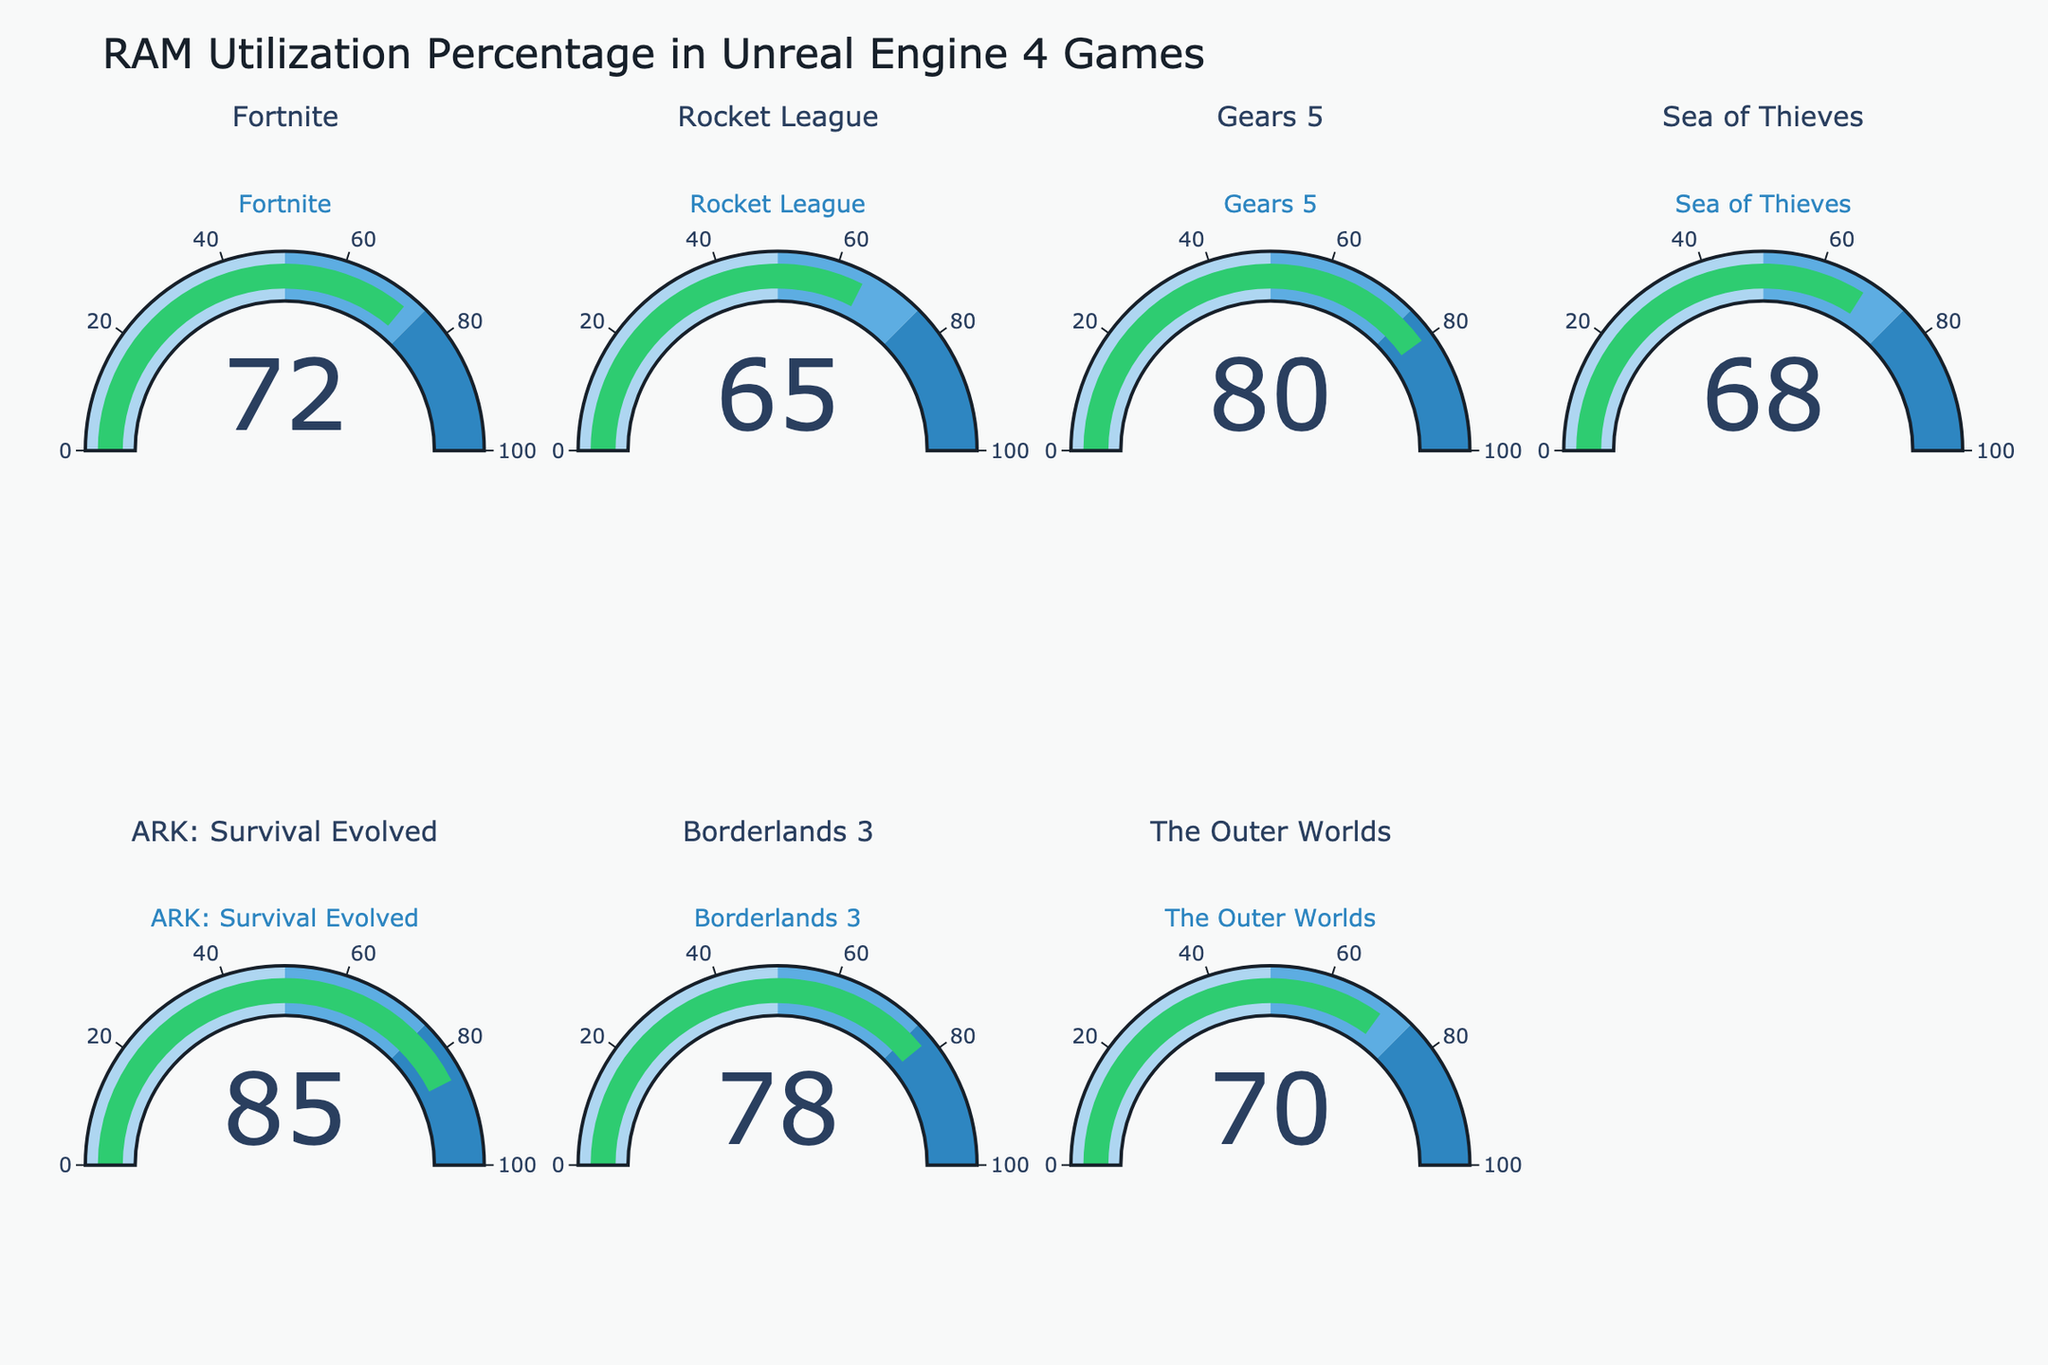How many games are displayed in the figure? Count the number of gauge charts displayed in the figure.
Answer: 7 What is the highest RAM utilization percentage displayed in the figure? Find the gauge chart with the highest value.
Answer: 85 What's the average RAM utilization percentage across all games? Sum all the RAM utilization percentages and then divide by the number of games: (72 + 65 + 80 + 68 + 85 + 78 + 70) / 7 = 74
Answer: 74 Which game has the lowest RAM utilization percentage? Identify the gauge chart with the smallest value.
Answer: Rocket League How much more RAM does ARK: Survival Evolved use compared to Sea of Thieves? Subtract the RAM utilization percentage of Sea of Thieves from ARK: Survival Evolved: 85 - 68 = 17
Answer: 17 Among the games displayed, which two have RAM utilization percentages closest to each other? Find the two percentages with the least difference: The closest values are Fortnite (72) and The Outer Worlds (70), with a difference of 72 - 70 = 2
Answer: Fortnite and The Outer Worlds What percentage of the games have a RAM utilization percentage greater than 75? Count the number of games with RAM utilization greater than 75 and divide by the total number of games: 3 games have values greater than 75 (Gears 5, ARK: Survival Evolved, Borderlands 3), so the percentage is (3/7) * 100 ≈ 43%
Answer: 43% Which has a higher RAM utilization, The Outer Worlds or Sea of Thieves? Compare the RAM utilization percentages of The Outer Worlds (70) and Sea of Thieves (68).
Answer: The Outer Worlds 